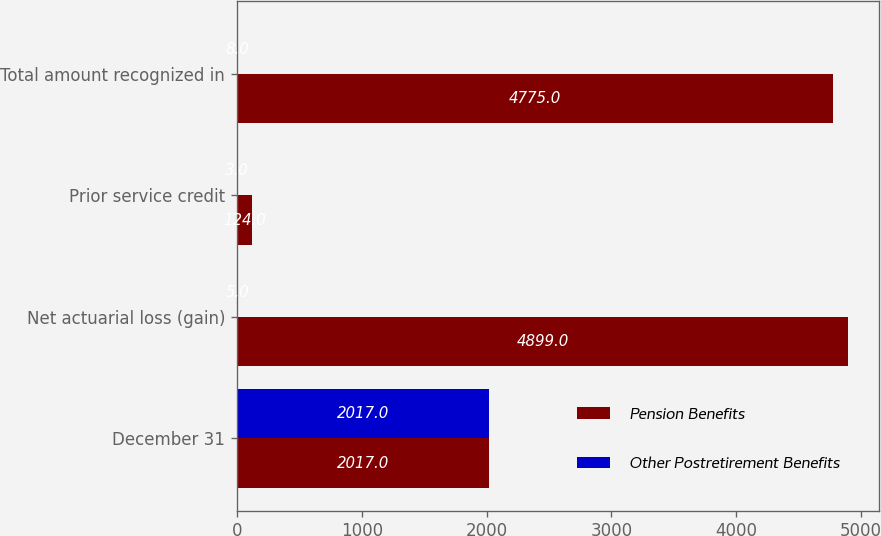Convert chart. <chart><loc_0><loc_0><loc_500><loc_500><stacked_bar_chart><ecel><fcel>December 31<fcel>Net actuarial loss (gain)<fcel>Prior service credit<fcel>Total amount recognized in<nl><fcel>Pension Benefits<fcel>2017<fcel>4899<fcel>124<fcel>4775<nl><fcel>Other Postretirement Benefits<fcel>2017<fcel>5<fcel>3<fcel>8<nl></chart> 